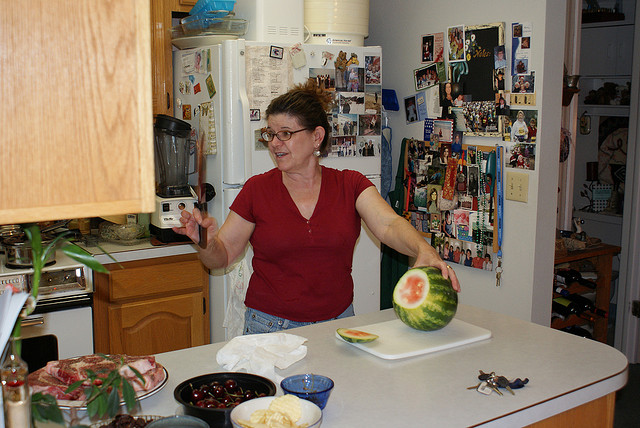How many bowls are visible? There are two bowls visible in the image, one appears to be filled with some cherries and another with some kind of dip or sauce. The presence of the bowls, along with other items like watermelon and keys, suggests a casual, domestic setting possibly prepping for a meal or social gathering. 